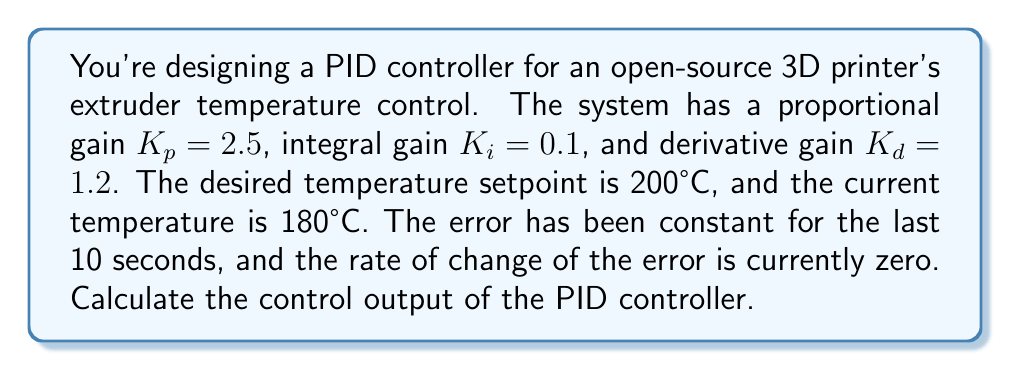Could you help me with this problem? To solve this problem, we'll use the PID controller equation and the given information. The PID controller equation is:

$$u(t) = K_p e(t) + K_i \int_0^t e(\tau) d\tau + K_d \frac{de(t)}{dt}$$

Where:
- $u(t)$ is the control output
- $e(t)$ is the error (setpoint - current value)
- $K_p$, $K_i$, and $K_d$ are the proportional, integral, and derivative gains respectively

Let's break down the problem step by step:

1. Calculate the error:
   $e(t) = \text{setpoint} - \text{current value} = 200°C - 180°C = 20°C$

2. Proportional term:
   $K_p e(t) = 2.5 \times 20 = 50$

3. Integral term:
   The error has been constant for 10 seconds, so:
   $K_i \int_0^t e(\tau) d\tau = K_i \times e \times t = 0.1 \times 20 \times 10 = 20$

4. Derivative term:
   The rate of change of the error is zero, so:
   $K_d \frac{de(t)}{dt} = 1.2 \times 0 = 0$

5. Sum up all terms:
   $u(t) = 50 + 20 + 0 = 70$

Therefore, the control output of the PID controller is 70.
Answer: 70 